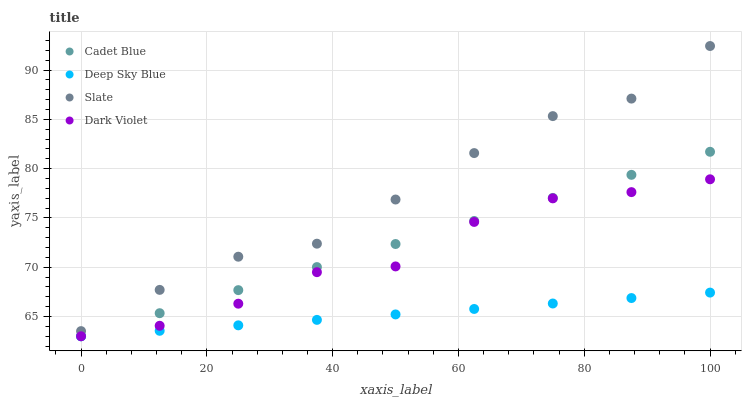Does Deep Sky Blue have the minimum area under the curve?
Answer yes or no. Yes. Does Slate have the maximum area under the curve?
Answer yes or no. Yes. Does Cadet Blue have the minimum area under the curve?
Answer yes or no. No. Does Cadet Blue have the maximum area under the curve?
Answer yes or no. No. Is Deep Sky Blue the smoothest?
Answer yes or no. Yes. Is Dark Violet the roughest?
Answer yes or no. Yes. Is Cadet Blue the smoothest?
Answer yes or no. No. Is Cadet Blue the roughest?
Answer yes or no. No. Does Cadet Blue have the lowest value?
Answer yes or no. Yes. Does Slate have the highest value?
Answer yes or no. Yes. Does Cadet Blue have the highest value?
Answer yes or no. No. Is Cadet Blue less than Slate?
Answer yes or no. Yes. Is Slate greater than Dark Violet?
Answer yes or no. Yes. Does Cadet Blue intersect Deep Sky Blue?
Answer yes or no. Yes. Is Cadet Blue less than Deep Sky Blue?
Answer yes or no. No. Is Cadet Blue greater than Deep Sky Blue?
Answer yes or no. No. Does Cadet Blue intersect Slate?
Answer yes or no. No. 